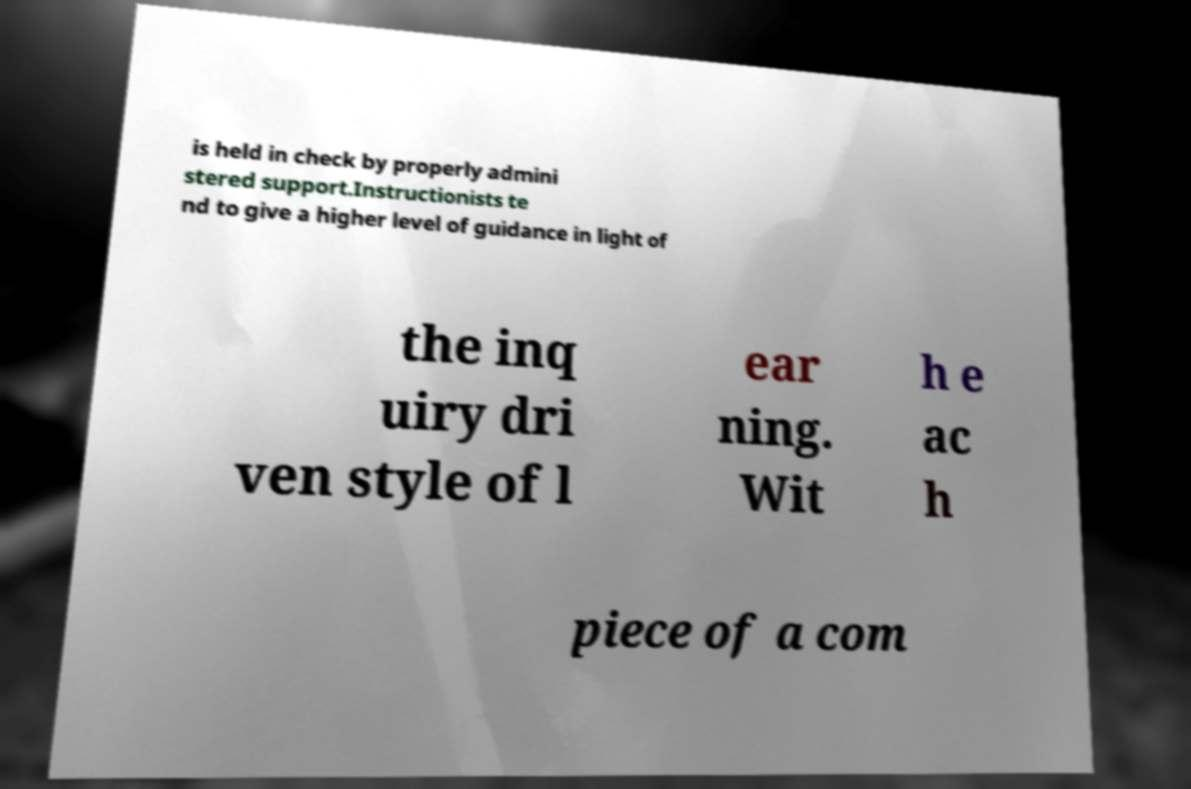For documentation purposes, I need the text within this image transcribed. Could you provide that? is held in check by properly admini stered support.Instructionists te nd to give a higher level of guidance in light of the inq uiry dri ven style of l ear ning. Wit h e ac h piece of a com 